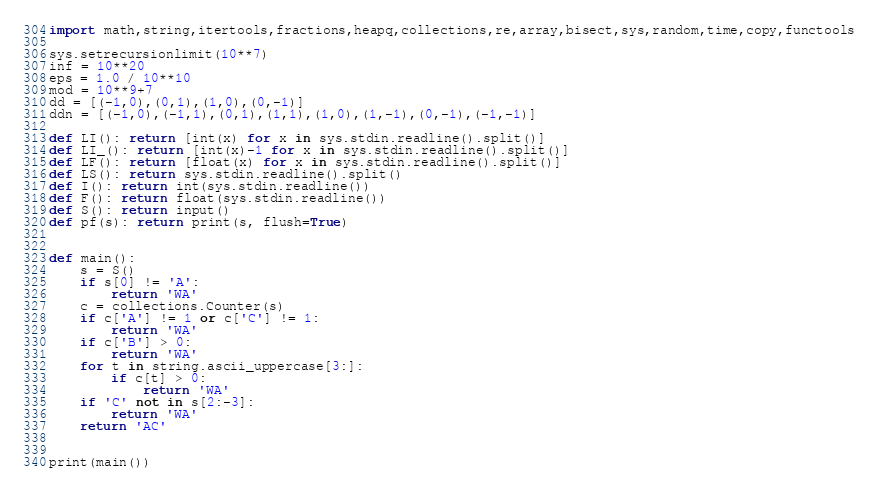<code> <loc_0><loc_0><loc_500><loc_500><_Python_>import math,string,itertools,fractions,heapq,collections,re,array,bisect,sys,random,time,copy,functools

sys.setrecursionlimit(10**7)
inf = 10**20
eps = 1.0 / 10**10
mod = 10**9+7
dd = [(-1,0),(0,1),(1,0),(0,-1)]
ddn = [(-1,0),(-1,1),(0,1),(1,1),(1,0),(1,-1),(0,-1),(-1,-1)]

def LI(): return [int(x) for x in sys.stdin.readline().split()]
def LI_(): return [int(x)-1 for x in sys.stdin.readline().split()]
def LF(): return [float(x) for x in sys.stdin.readline().split()]
def LS(): return sys.stdin.readline().split()
def I(): return int(sys.stdin.readline())
def F(): return float(sys.stdin.readline())
def S(): return input()
def pf(s): return print(s, flush=True)


def main():
    s = S()
    if s[0] != 'A':
        return 'WA'
    c = collections.Counter(s)
    if c['A'] != 1 or c['C'] != 1:
        return 'WA'
    if c['B'] > 0:
        return 'WA'
    for t in string.ascii_uppercase[3:]:
        if c[t] > 0:
            return 'WA'
    if 'C' not in s[2:-3]:
        return 'WA'
    return 'AC'


print(main())
</code> 